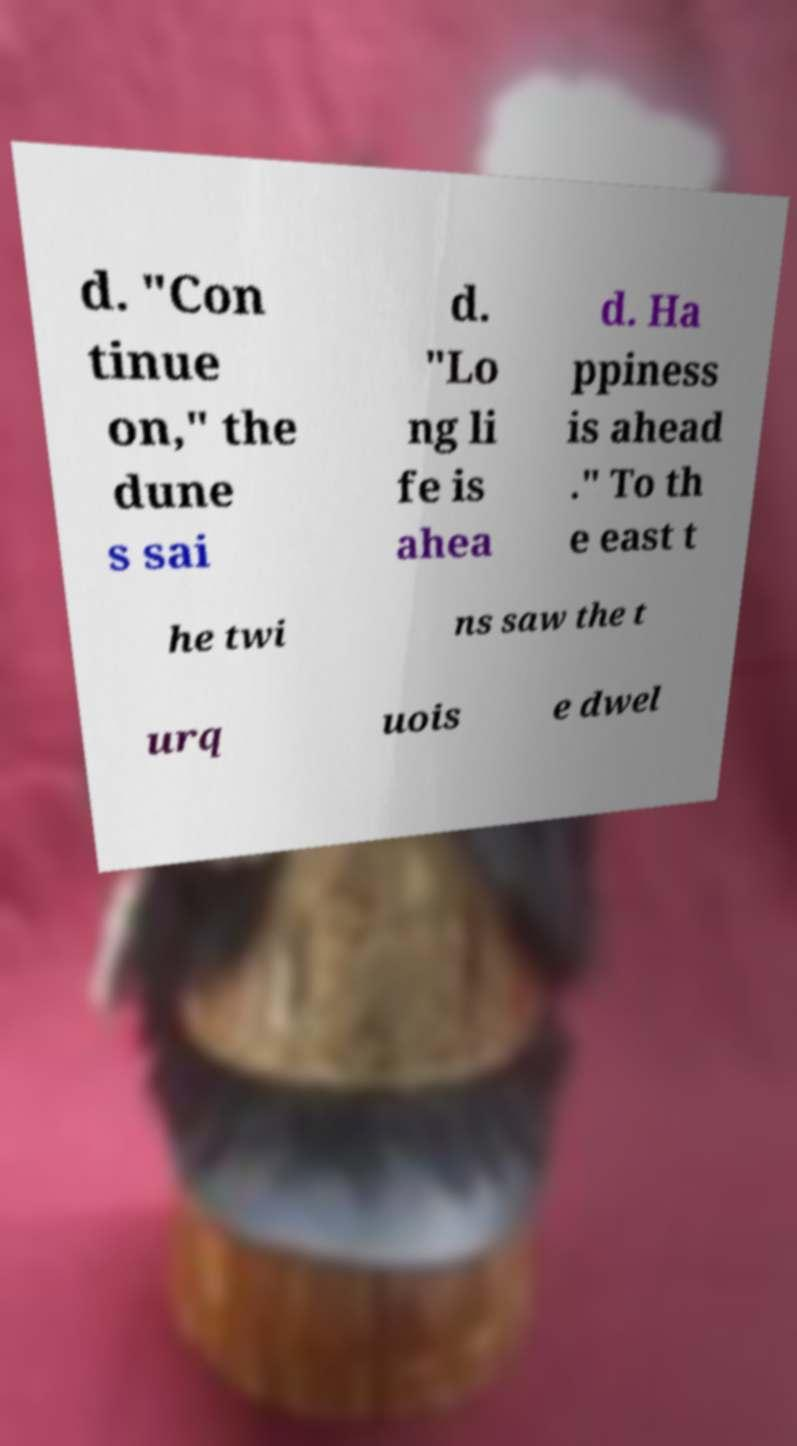Could you extract and type out the text from this image? d. "Con tinue on," the dune s sai d. "Lo ng li fe is ahea d. Ha ppiness is ahead ." To th e east t he twi ns saw the t urq uois e dwel 